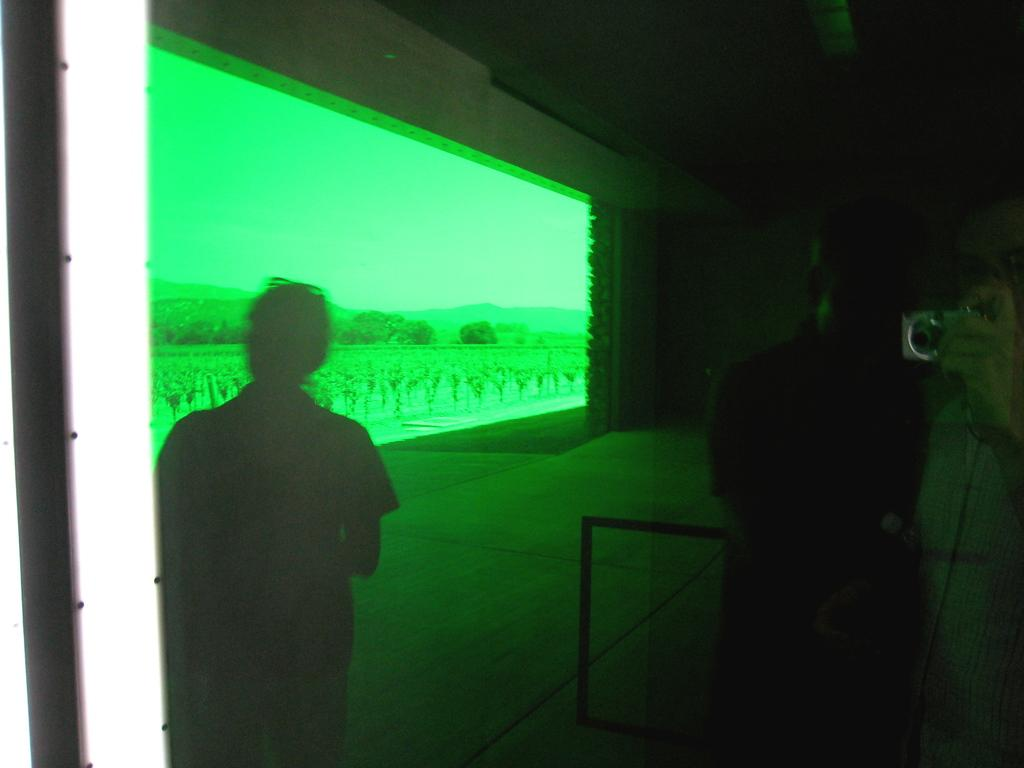What is the overall lighting condition in the image? The image is dark. What are the people in the image doing? There are people standing in the image. Can you identify any specific object or action being performed by one of the people? One person is holding a camera. What can be seen in the background of the image? There is a screen in the background of the image, with trees and the sky visible on it. What type of church can be seen in the image? There is no church present in the image. Do the people in the image believe in a particular religion? The image does not provide any information about the beliefs of the people in the image. 